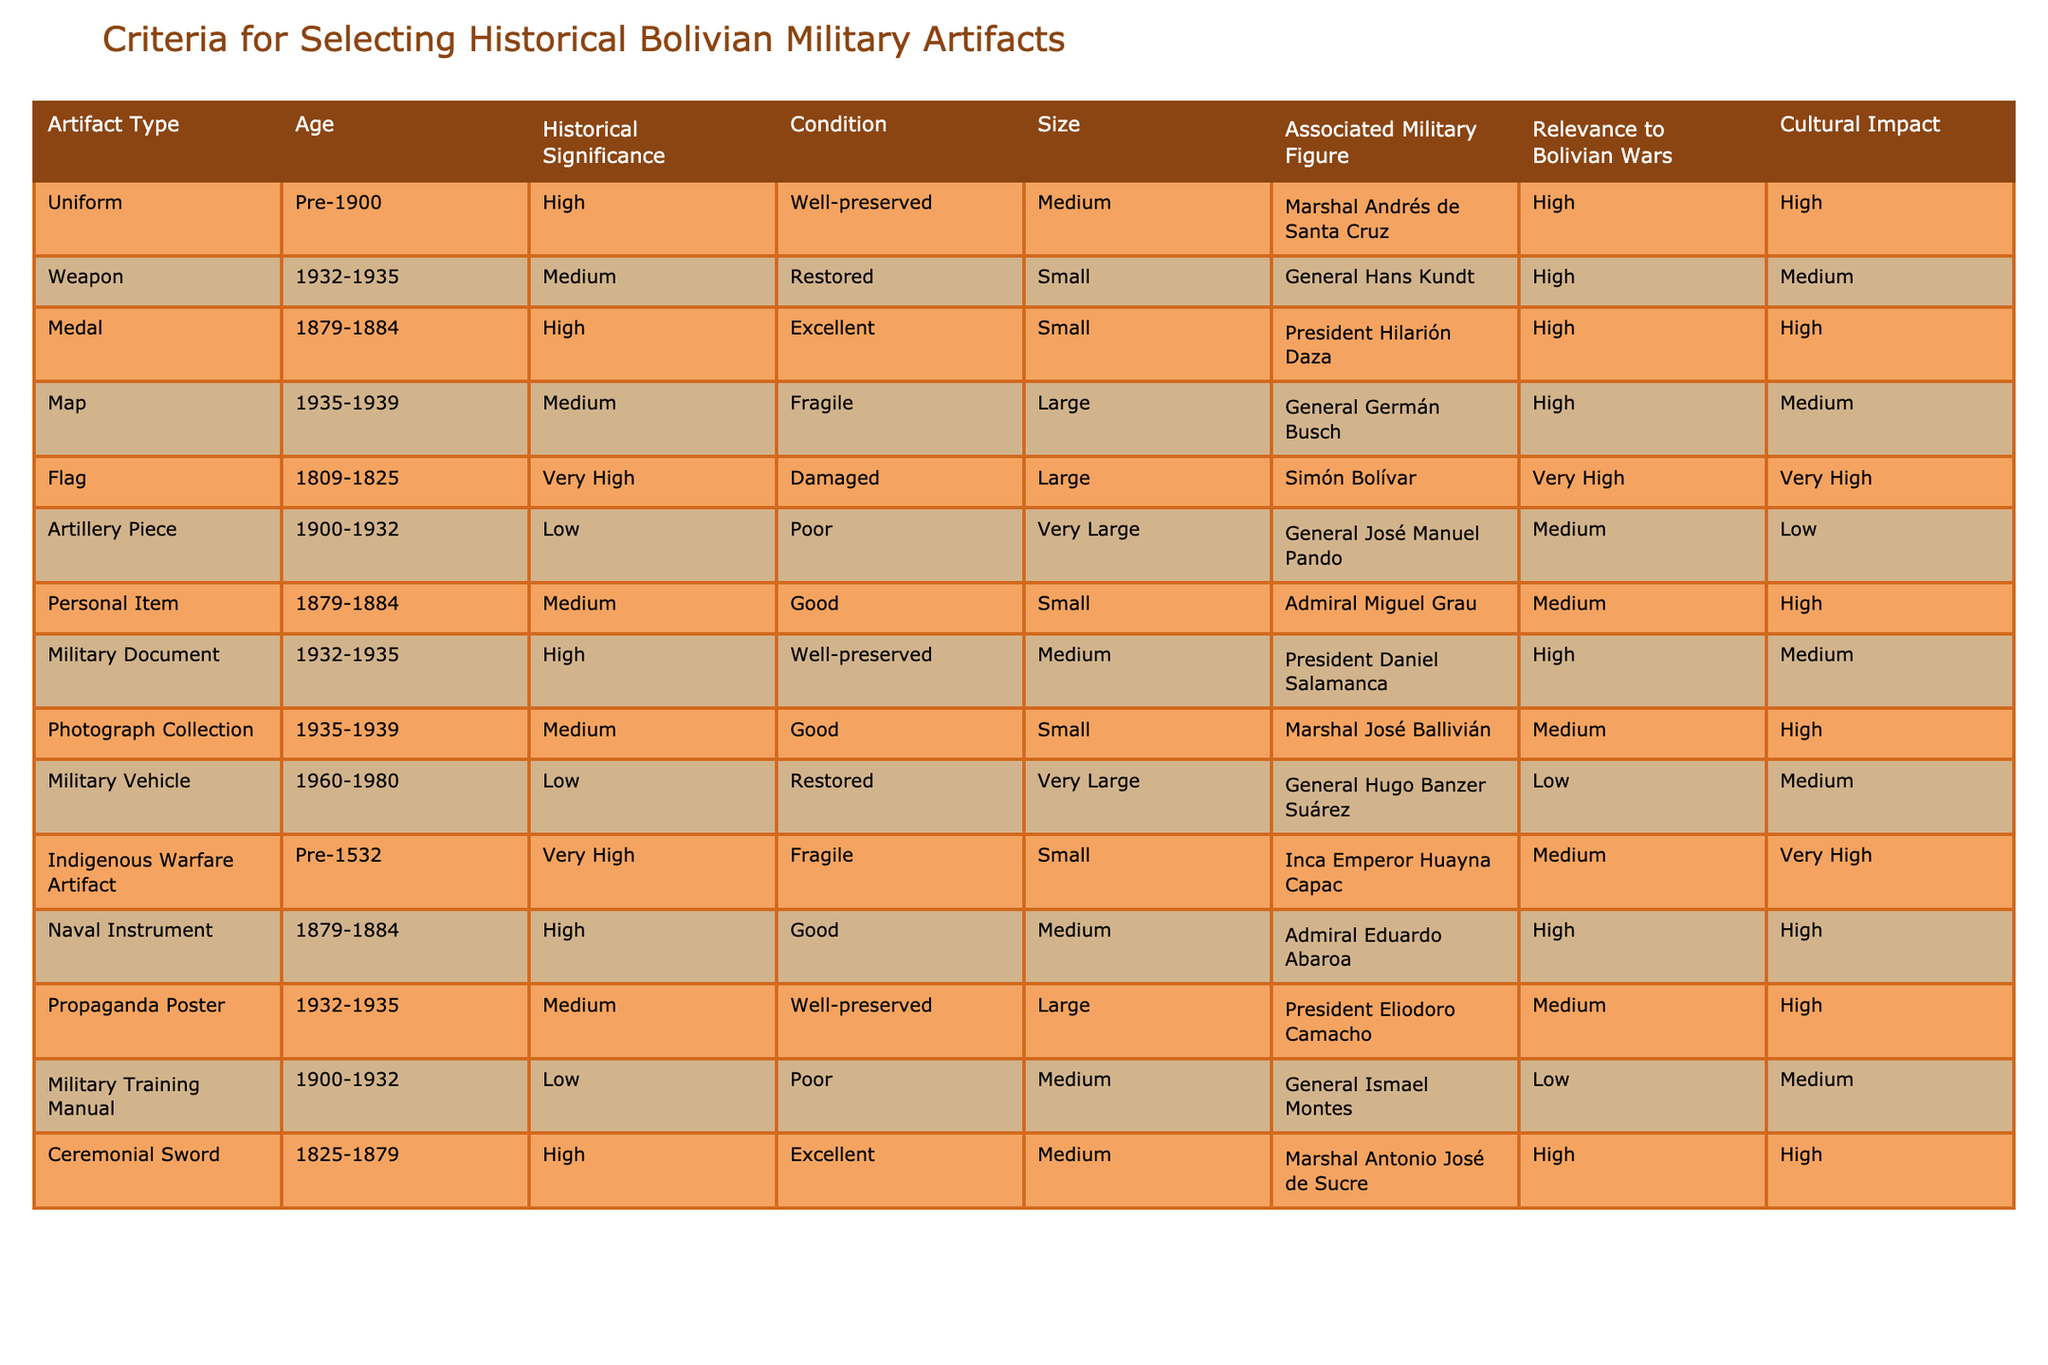What artifact type has the highest historical significance? The "Flag" has a historical significance rated as "Very High," which is the highest rating compared to the other artifacts.
Answer: Flag How many artifacts are classified as "Medium" in condition? There are 6 artifacts listed with a condition rating of "Medium," which include three weapons, a photograph collection, a propaganda poster, and a military document.
Answer: 6 Is there any artifact associated with Simón Bolívar? Yes, the "Flag" is associated with Simón Bolívar, as indicated under the "Associated Military Figure" column.
Answer: Yes What is the average size of the artifacts categorized as "Large"? There are three "Large" artifacts: Flag (Large), Map (Large), and Propaganda Poster (Large), which can be considered as having an average size since they all fall under the same category. Therefore, the average size is also "Large."
Answer: Large Which artifact is in the worst condition? The "Artillery Piece" is in the "Poor" condition, which is the worst condition rating in the table.
Answer: Artillery Piece What is the total number of artifacts that are unique in historical significance? Unique historical significance values include "Very High," "High," "Medium," and "Low," resulting in a total of 7 unique artifacts when counting each distinct historical significance for the artifacts listed.
Answer: 7 Which military figure has the most artifacts associated with them? Marshal Antonio José de Sucre, who is associated with the "Ceremonial Sword," rated as "High" in historical significance, is the only one listed more than once, and General Hugo Banzer Suárez has one associated artifact. Therefore, the answer is Subgroups rather than individual markers.
Answer: 1 Do any artifacts relate to the period of the Bolivian Wars? Yes, several artifacts, such as medals and uniforms, correspond to the historical timeline of the Bolivian Wars including the "Uniform" and "Medal," which have high relevance.
Answer: Yes 